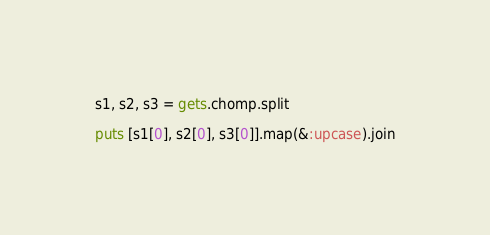<code> <loc_0><loc_0><loc_500><loc_500><_Ruby_>s1, s2, s3 = gets.chomp.split

puts [s1[0], s2[0], s3[0]].map(&:upcase).join
</code> 